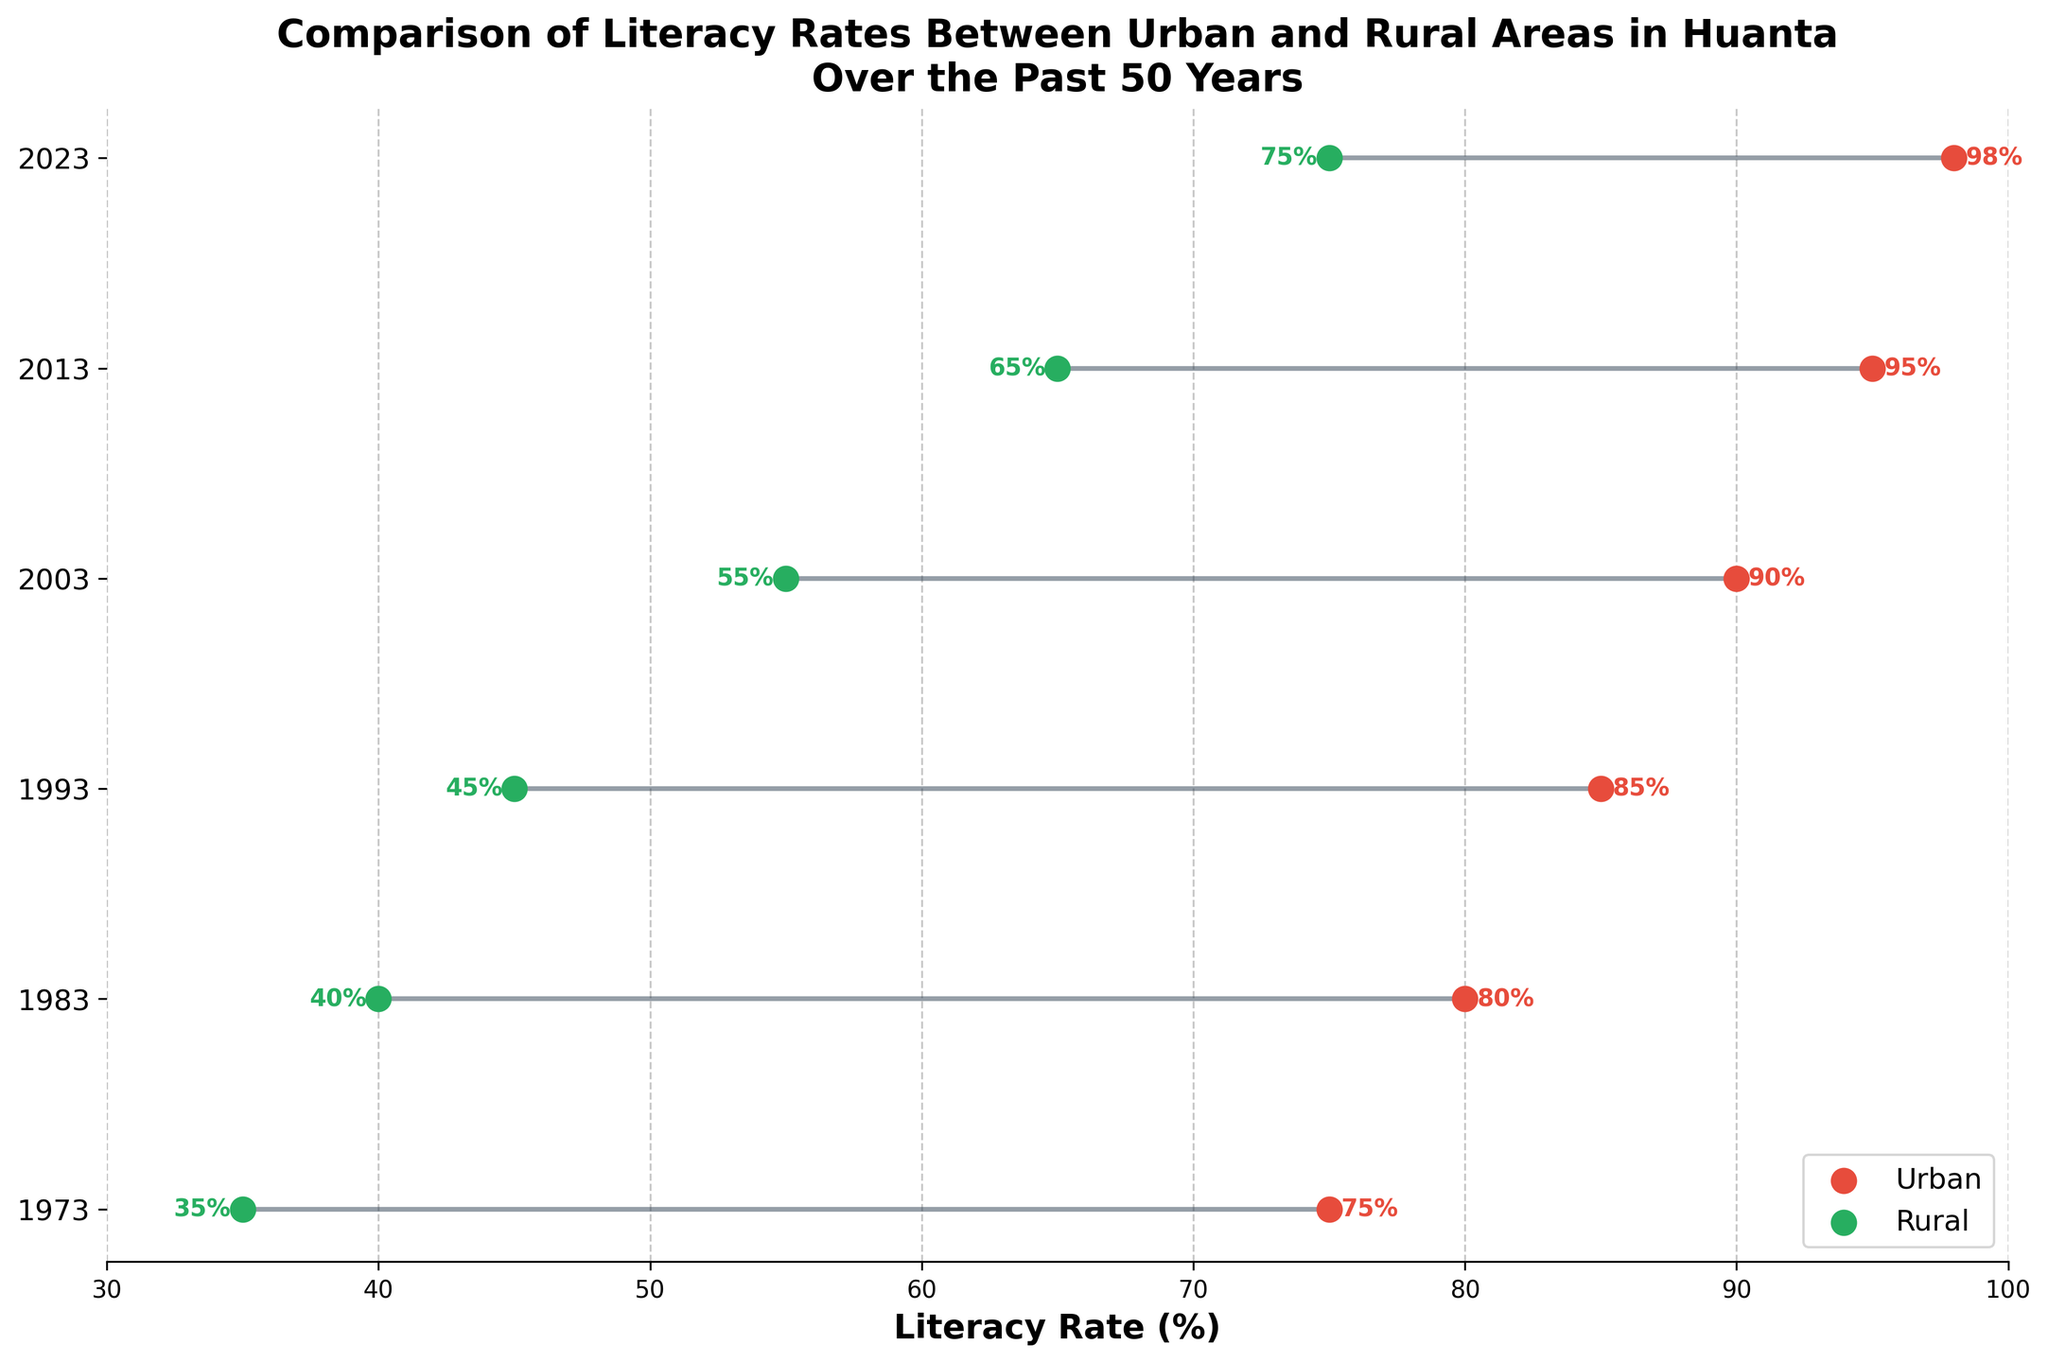What is the title of the plot? The title of the plot is written at the top of the figure. By reading it, we can determine that the title is "Comparison of Literacy Rates Between Urban and Rural Areas in Huanta Over the Past 50 Years."
Answer: Comparison of Literacy Rates Between Urban and Rural Areas in Huanta Over the Past 50 Years What colors represent urban and rural areas in the plot? The plots use different colors for urban and rural areas to distinguish them visually. By observing the legend, the urban areas are represented by red, and the rural areas are represented by green.
Answer: Red for urban, green for rural How many years are covered in this plot? The plot uses different points along the y-axis to represent different years. By counting these points, we can see that there are 6 different years shown.
Answer: 6 years What is the literacy rate for rural areas in 1983? Look at the y-axis for 1983; then, follow the green point or the label near it, which represents the rural area. The literacy rate for rural areas in 1983 is shown as 40%.
Answer: 40% What is the increase in urban literacy rate from 1973 to 2023? To find the difference, subtract the literacy rate in 1973 from the literacy rate in 2023 for urban areas. This is calculated as 98% - 75% = 23%.
Answer: 23% In which year did the rural literacy rate first surpass 50%? Follow the green points along the years and observe their values until the green point exceeds 50%. The earliest point where rural literacy surpasses 50% is in the year 2003.
Answer: 2003 How does the difference in literacy rates between urban and rural areas change from 1973 to 2023? Calculate the differences for both years: In 1973, the difference is 75% (urban) - 35% (rural) = 40%. In 2023, it is 98% (urban) - 75% (rural) = 23%. The difference decreases from 40% to 23%.
Answer: Decreases from 40% to 23% Which year shows the smallest gap in literacy rates between urban and rural areas? Find the year with the smallest difference by comparing the gaps for each year: 1973 (40%), 1983 (40%), 1993 (40%), 2003 (35%), 2013 (30%), 2023 (23%). The year 2023 shows the smallest gap of 23%.
Answer: 2023 Identify the year with the highest increase in rural literacy rate compared to the previous decade. Calculate the decade-over-decade increase for rural areas: 1983-1973 (5%), 1993-1983 (5%), 2003-1993 (10%), 2013-2003 (10%), 2023-2013 (10%). The highest increase occurs from 2003 to 2013, and from 2013 to 2023, both are 10%.
Answer: 2003-2013 and 2013-2023 